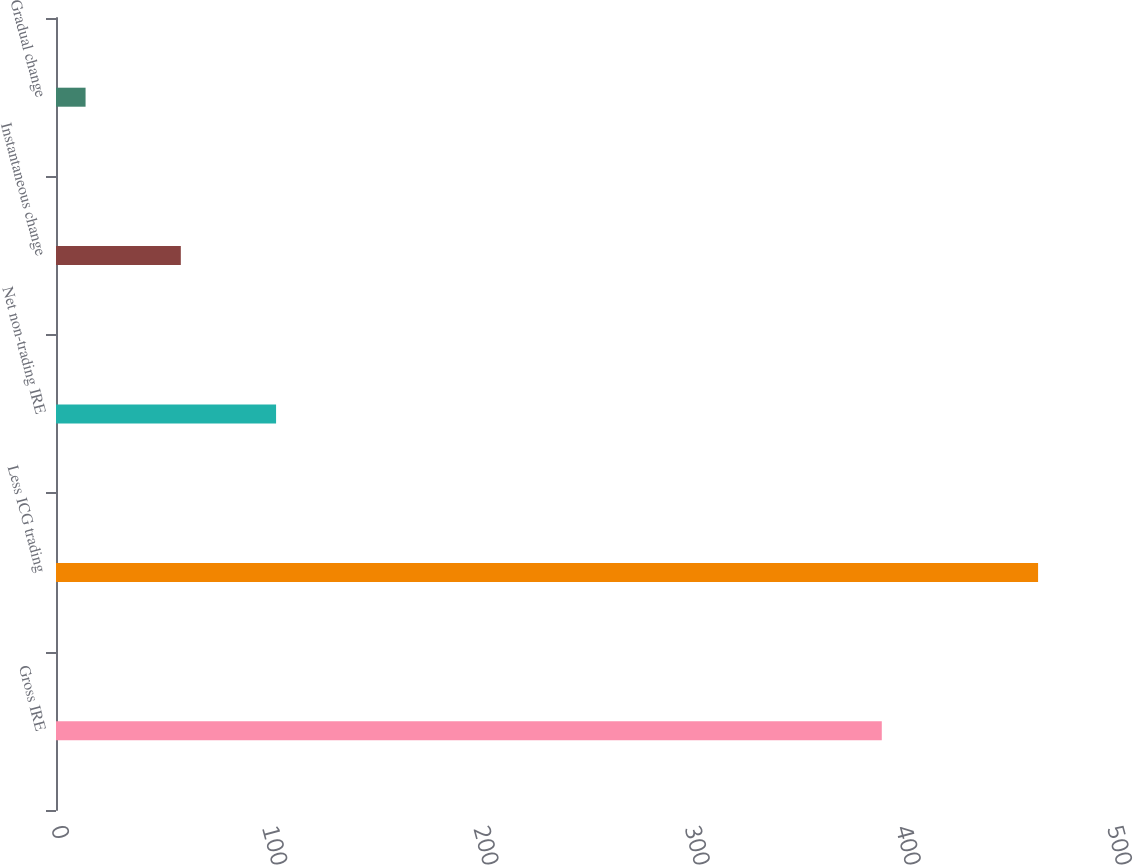Convert chart. <chart><loc_0><loc_0><loc_500><loc_500><bar_chart><fcel>Gross IRE<fcel>Less ICG trading<fcel>Net non-trading IRE<fcel>Instantaneous change<fcel>Gradual change<nl><fcel>391<fcel>465<fcel>104.2<fcel>59.1<fcel>14<nl></chart> 